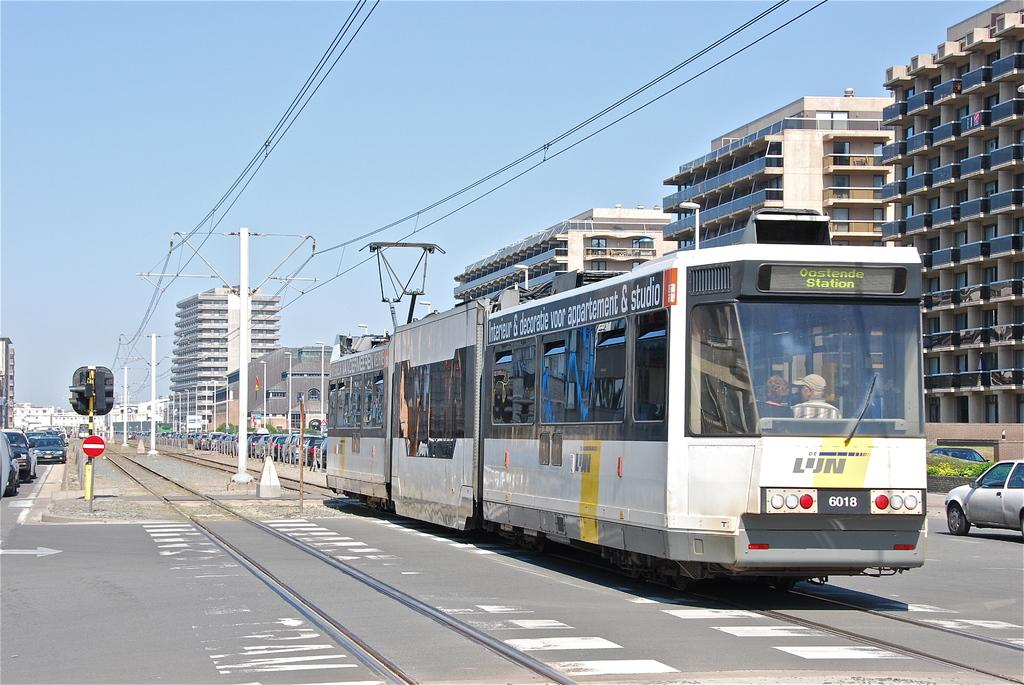What type of vehicles can be seen on the road in the image? There are vehicles on the road in the image. What mode of transportation is present on the tramway track? There is a tram on the tramway track in the image. What structures are present in the image? There are poles, lights, and buildings in the image. What is the background of the image? The sky is visible in the background of the image. Can you see a volcano erupting in the image? There is no volcano present in the image. Is there a basketball court visible in the image? There is no basketball court present in the image. 